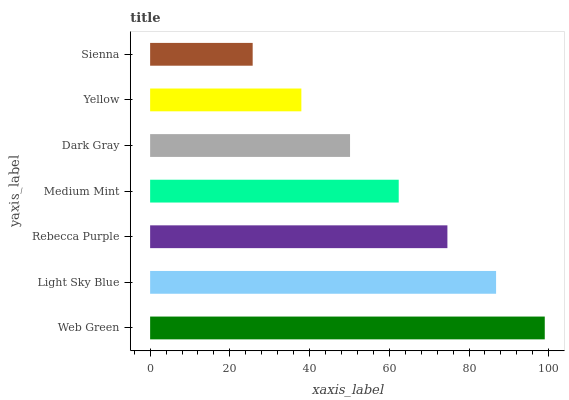Is Sienna the minimum?
Answer yes or no. Yes. Is Web Green the maximum?
Answer yes or no. Yes. Is Light Sky Blue the minimum?
Answer yes or no. No. Is Light Sky Blue the maximum?
Answer yes or no. No. Is Web Green greater than Light Sky Blue?
Answer yes or no. Yes. Is Light Sky Blue less than Web Green?
Answer yes or no. Yes. Is Light Sky Blue greater than Web Green?
Answer yes or no. No. Is Web Green less than Light Sky Blue?
Answer yes or no. No. Is Medium Mint the high median?
Answer yes or no. Yes. Is Medium Mint the low median?
Answer yes or no. Yes. Is Web Green the high median?
Answer yes or no. No. Is Sienna the low median?
Answer yes or no. No. 